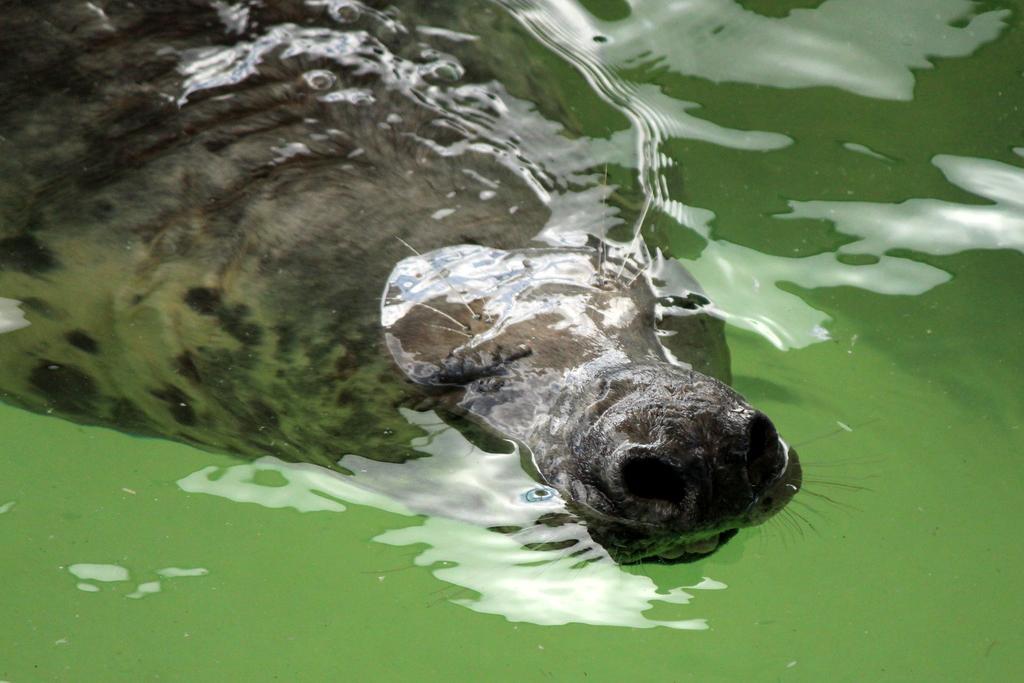Please provide a concise description of this image. In this image, we can see an animal in the water. 